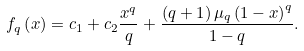<formula> <loc_0><loc_0><loc_500><loc_500>f _ { q } \left ( x \right ) = c _ { 1 } + c _ { 2 } \frac { x ^ { q } } { q } + \frac { { \left ( { q + 1 } \right ) \mu _ { q } \left ( { 1 - x } \right ) ^ { q } } } { 1 - q } .</formula> 